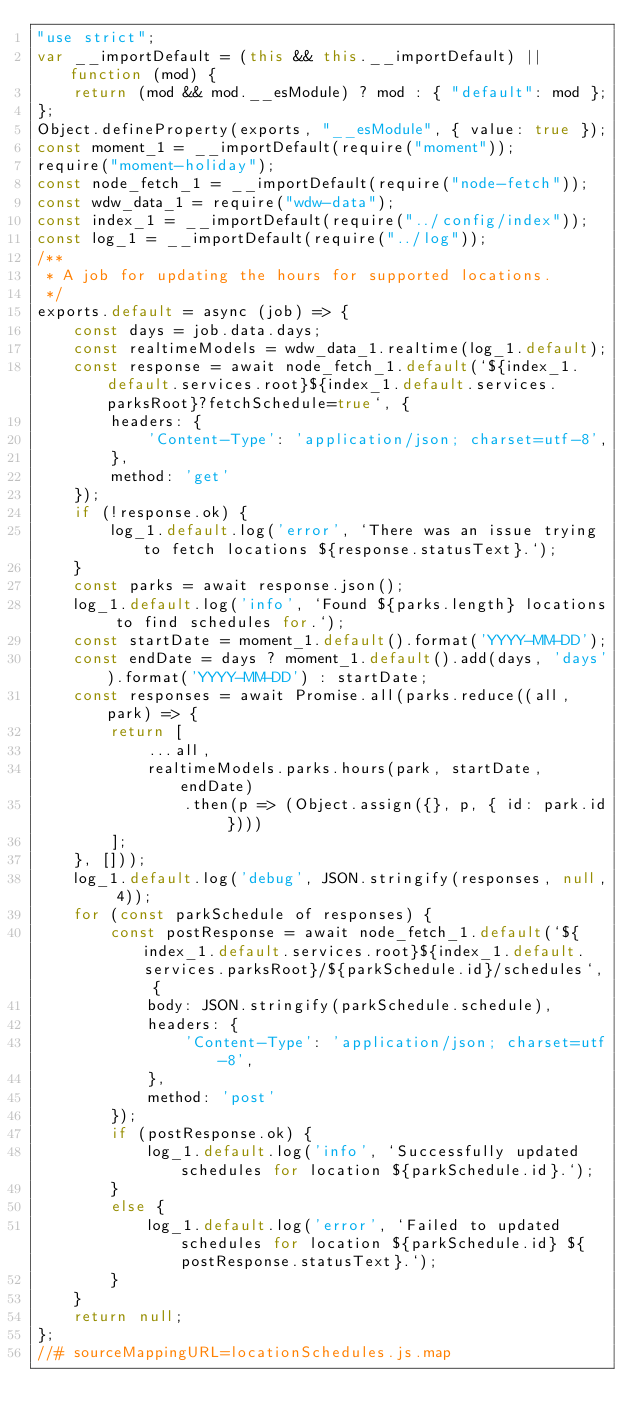Convert code to text. <code><loc_0><loc_0><loc_500><loc_500><_JavaScript_>"use strict";
var __importDefault = (this && this.__importDefault) || function (mod) {
    return (mod && mod.__esModule) ? mod : { "default": mod };
};
Object.defineProperty(exports, "__esModule", { value: true });
const moment_1 = __importDefault(require("moment"));
require("moment-holiday");
const node_fetch_1 = __importDefault(require("node-fetch"));
const wdw_data_1 = require("wdw-data");
const index_1 = __importDefault(require("../config/index"));
const log_1 = __importDefault(require("../log"));
/**
 * A job for updating the hours for supported locations.
 */
exports.default = async (job) => {
    const days = job.data.days;
    const realtimeModels = wdw_data_1.realtime(log_1.default);
    const response = await node_fetch_1.default(`${index_1.default.services.root}${index_1.default.services.parksRoot}?fetchSchedule=true`, {
        headers: {
            'Content-Type': 'application/json; charset=utf-8',
        },
        method: 'get'
    });
    if (!response.ok) {
        log_1.default.log('error', `There was an issue trying to fetch locations ${response.statusText}.`);
    }
    const parks = await response.json();
    log_1.default.log('info', `Found ${parks.length} locations to find schedules for.`);
    const startDate = moment_1.default().format('YYYY-MM-DD');
    const endDate = days ? moment_1.default().add(days, 'days').format('YYYY-MM-DD') : startDate;
    const responses = await Promise.all(parks.reduce((all, park) => {
        return [
            ...all,
            realtimeModels.parks.hours(park, startDate, endDate)
                .then(p => (Object.assign({}, p, { id: park.id })))
        ];
    }, []));
    log_1.default.log('debug', JSON.stringify(responses, null, 4));
    for (const parkSchedule of responses) {
        const postResponse = await node_fetch_1.default(`${index_1.default.services.root}${index_1.default.services.parksRoot}/${parkSchedule.id}/schedules`, {
            body: JSON.stringify(parkSchedule.schedule),
            headers: {
                'Content-Type': 'application/json; charset=utf-8',
            },
            method: 'post'
        });
        if (postResponse.ok) {
            log_1.default.log('info', `Successfully updated schedules for location ${parkSchedule.id}.`);
        }
        else {
            log_1.default.log('error', `Failed to updated schedules for location ${parkSchedule.id} ${postResponse.statusText}.`);
        }
    }
    return null;
};
//# sourceMappingURL=locationSchedules.js.map</code> 